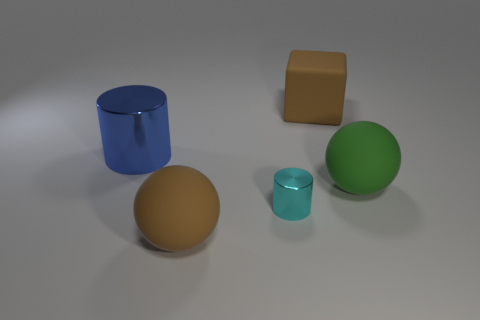There is a brown thing right of the tiny cyan shiny cylinder; does it have the same shape as the large brown object in front of the rubber cube?
Keep it short and to the point. No. What number of other things are the same color as the big block?
Your answer should be compact. 1. Is the material of the large sphere that is left of the small object the same as the blue thing?
Provide a succinct answer. No. Is there any other thing that has the same size as the green object?
Make the answer very short. Yes. Is the number of blue metallic cylinders in front of the large green sphere less than the number of big blue shiny cylinders that are in front of the tiny cylinder?
Your answer should be very brief. No. Is there any other thing that is the same shape as the cyan metal object?
Provide a short and direct response. Yes. What material is the thing that is the same color as the matte cube?
Your answer should be compact. Rubber. What number of brown things are in front of the ball that is right of the large brown matte thing in front of the large cube?
Keep it short and to the point. 1. There is a brown ball; what number of cylinders are to the right of it?
Make the answer very short. 1. How many big balls have the same material as the small cylinder?
Provide a succinct answer. 0. 